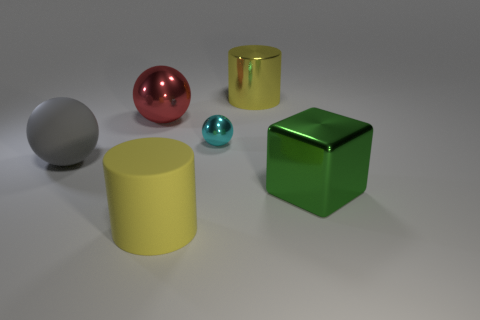Subtract all tiny spheres. How many spheres are left? 2 Subtract all red balls. How many balls are left? 2 Subtract all cylinders. How many objects are left? 4 Add 3 big yellow metallic objects. How many objects exist? 9 Subtract 1 cubes. How many cubes are left? 0 Add 5 large rubber cylinders. How many large rubber cylinders are left? 6 Add 3 big gray matte things. How many big gray matte things exist? 4 Subtract 0 brown balls. How many objects are left? 6 Subtract all green balls. Subtract all purple cylinders. How many balls are left? 3 Subtract all green metallic spheres. Subtract all yellow things. How many objects are left? 4 